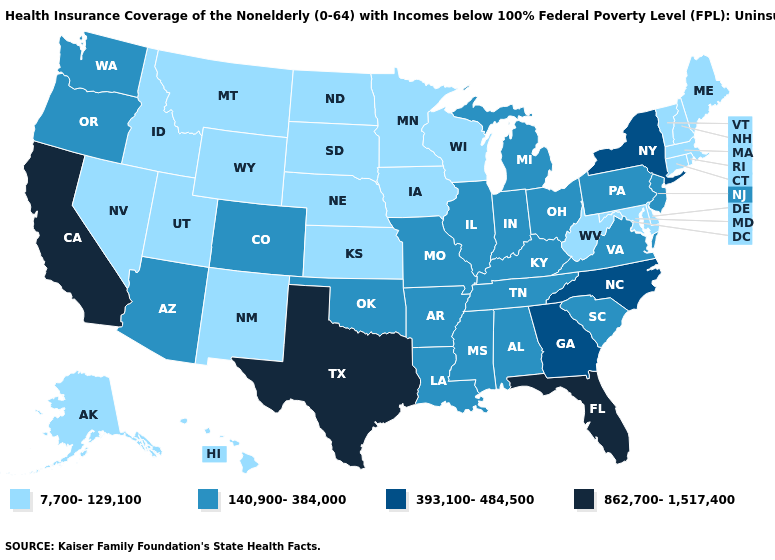Does Colorado have the highest value in the West?
Short answer required. No. What is the value of Wyoming?
Answer briefly. 7,700-129,100. Does Massachusetts have the highest value in the Northeast?
Write a very short answer. No. Name the states that have a value in the range 140,900-384,000?
Be succinct. Alabama, Arizona, Arkansas, Colorado, Illinois, Indiana, Kentucky, Louisiana, Michigan, Mississippi, Missouri, New Jersey, Ohio, Oklahoma, Oregon, Pennsylvania, South Carolina, Tennessee, Virginia, Washington. Which states have the highest value in the USA?
Write a very short answer. California, Florida, Texas. Name the states that have a value in the range 7,700-129,100?
Give a very brief answer. Alaska, Connecticut, Delaware, Hawaii, Idaho, Iowa, Kansas, Maine, Maryland, Massachusetts, Minnesota, Montana, Nebraska, Nevada, New Hampshire, New Mexico, North Dakota, Rhode Island, South Dakota, Utah, Vermont, West Virginia, Wisconsin, Wyoming. What is the lowest value in the USA?
Short answer required. 7,700-129,100. Name the states that have a value in the range 393,100-484,500?
Concise answer only. Georgia, New York, North Carolina. Which states have the lowest value in the MidWest?
Give a very brief answer. Iowa, Kansas, Minnesota, Nebraska, North Dakota, South Dakota, Wisconsin. Is the legend a continuous bar?
Be succinct. No. What is the highest value in the USA?
Give a very brief answer. 862,700-1,517,400. Which states hav the highest value in the West?
Be succinct. California. Does Kansas have the highest value in the USA?
Give a very brief answer. No. What is the highest value in states that border North Carolina?
Keep it brief. 393,100-484,500. Among the states that border Delaware , does Pennsylvania have the highest value?
Concise answer only. Yes. 